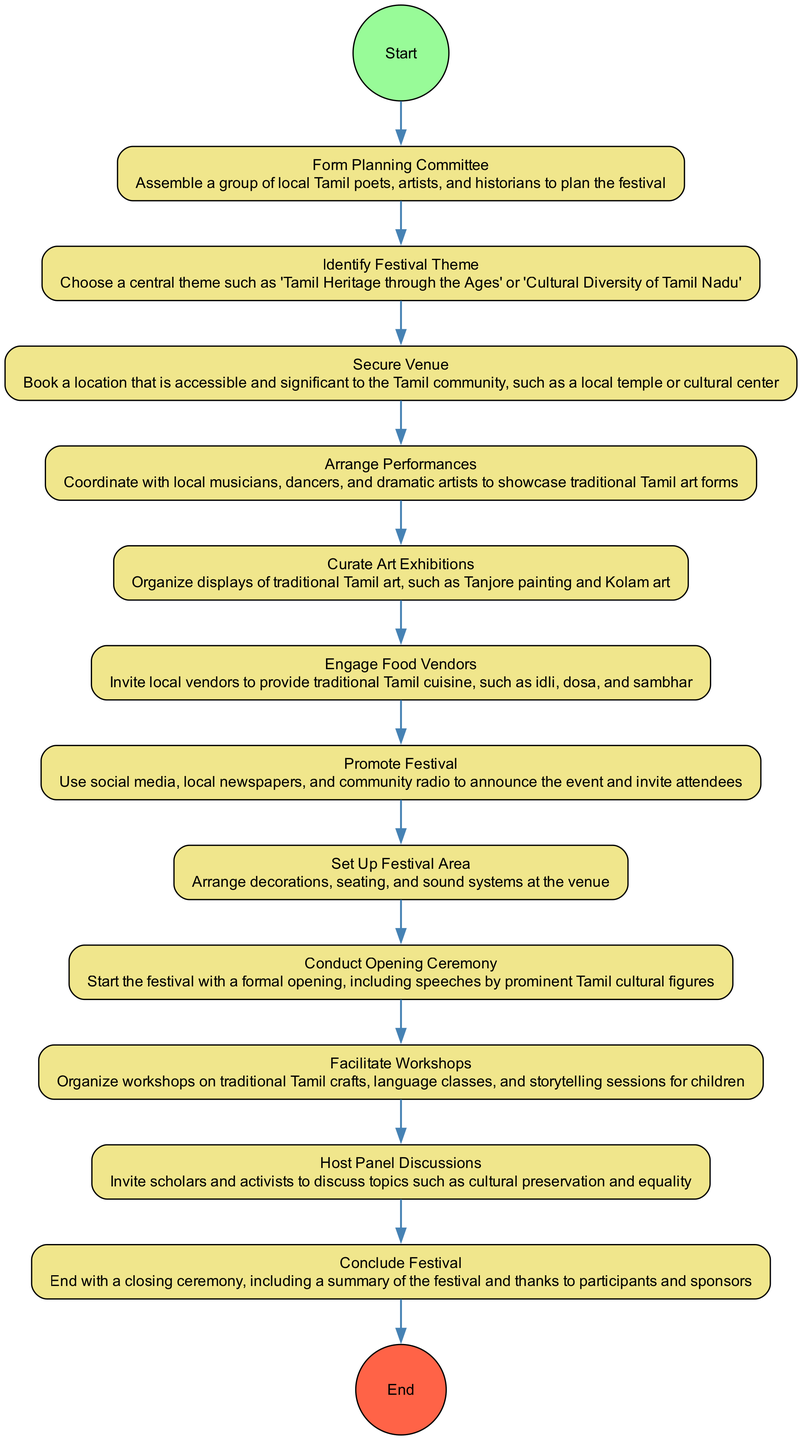What is the first activity in the diagram? The first activity is "Form Planning Committee", which is directly linked to the start node. This is evident because it is the first activity listed in the sequence of activities.
Answer: Form Planning Committee How many activities are there in total? By counting each activity listed in the diagram, there are 12 distinct activities observed, from "Form Planning Committee" to "Conclude Festival".
Answer: 12 What is the last activity in the diagram? The last activity is "Conclude Festival", which is connected to the end node. It follows the "Host Panel Discussions" and indicates the conclusion of the festival.
Answer: Conclude Festival Which activity comes after "Secure Venue"? The activity that follows "Secure Venue" is "Arrange Performances". This is shown in the diagram where "Secure Venue" has an edge pointing to "Arrange Performances".
Answer: Arrange Performances Which two activities are connected directly? "Promote Festival" and "Set Up Festival Area" are directly connected, as indicated by the edge between them in the flow of the diagram.
Answer: Promote Festival, Set Up Festival Area How many activities follow the "Facilitate Workshops"? Only one activity follows "Facilitate Workshops", which is "Host Panel Discussions". The diagram shows a single edge extending from "Facilitate Workshops" to "Host Panel Discussions".
Answer: 1 What is the relationship between "Identify Festival Theme" and "Secure Venue"? The relationship is sequential; "Identify Festival Theme" directly precedes "Secure Venue", indicating that securing the venue follows the identification of the festival theme in the planning process.
Answer: Sequential Which activity requires engaging food vendors? "Engage Food Vendors" is a distinct activity which follows "Curate Art Exhibitions". The diagram clearly states that vendors are engaged for providing cuisine after exhibitions are curated.
Answer: Engage Food Vendors What signifies the beginning of the festival in the diagram? The beginning of the festival is marked by "Conduct Opening Ceremony", which serves as a formal start after the festival area has been set up. This is observed in the progression of activities listed.
Answer: Conduct Opening Ceremony 